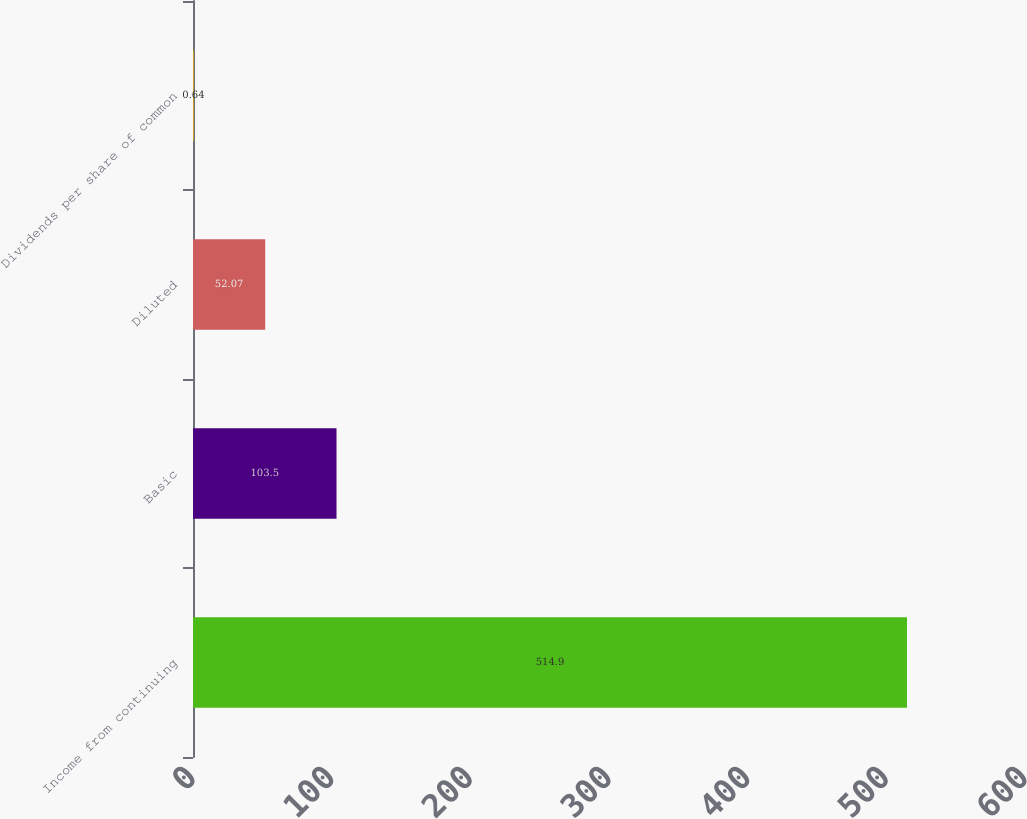<chart> <loc_0><loc_0><loc_500><loc_500><bar_chart><fcel>Income from continuing<fcel>Basic<fcel>Diluted<fcel>Dividends per share of common<nl><fcel>514.9<fcel>103.5<fcel>52.07<fcel>0.64<nl></chart> 